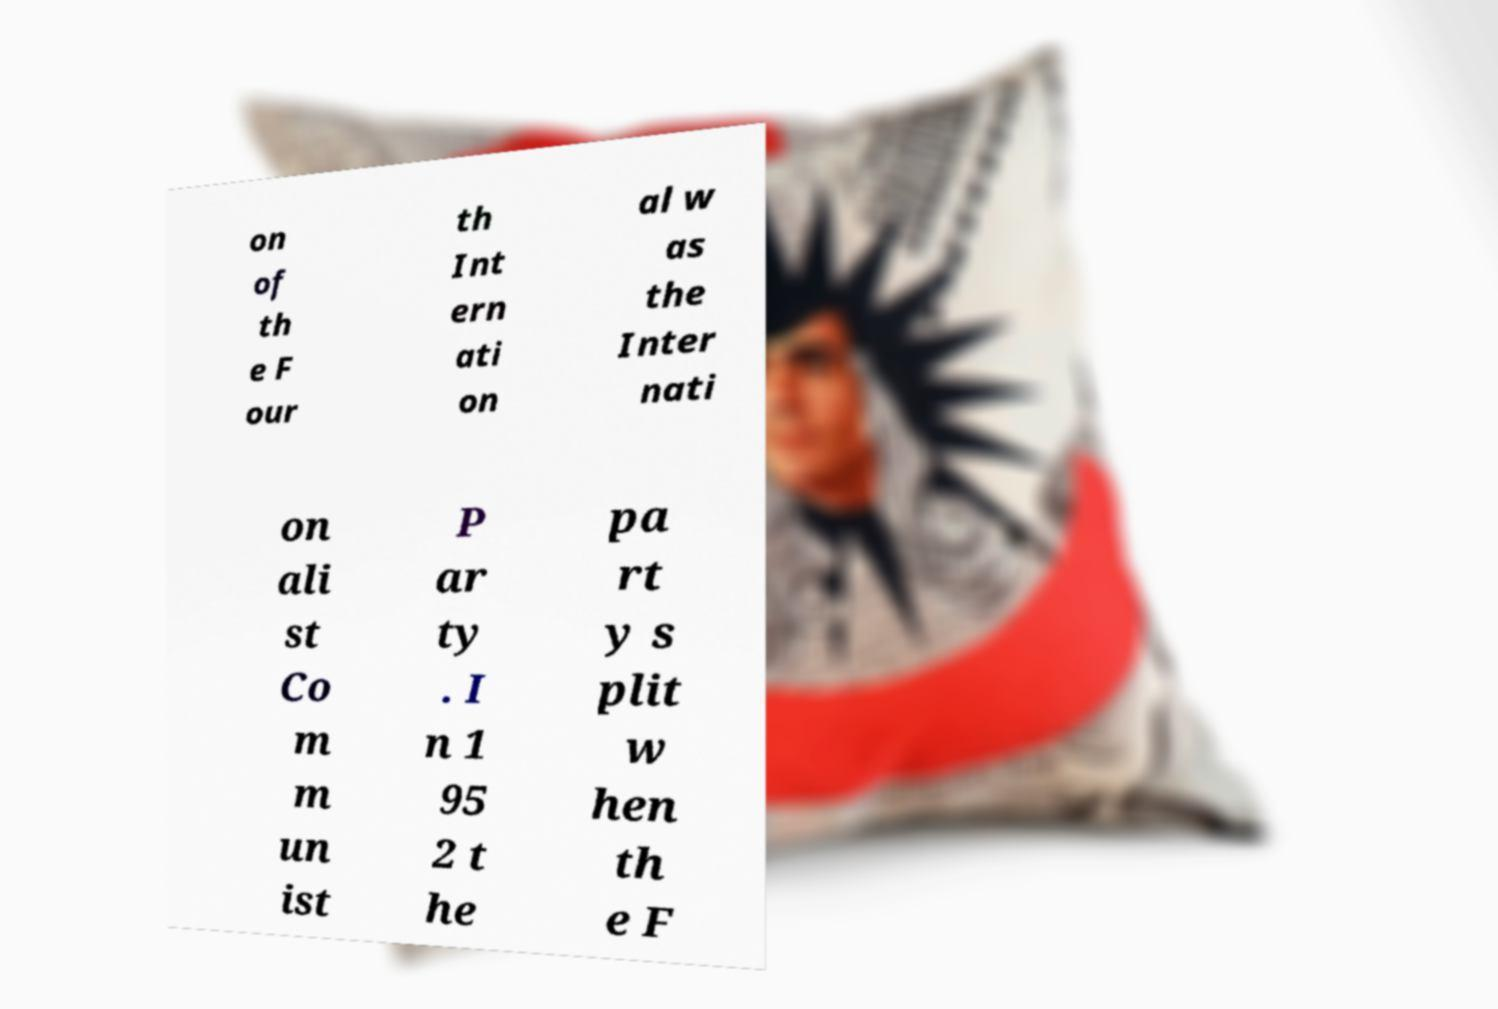Please identify and transcribe the text found in this image. on of th e F our th Int ern ati on al w as the Inter nati on ali st Co m m un ist P ar ty . I n 1 95 2 t he pa rt y s plit w hen th e F 